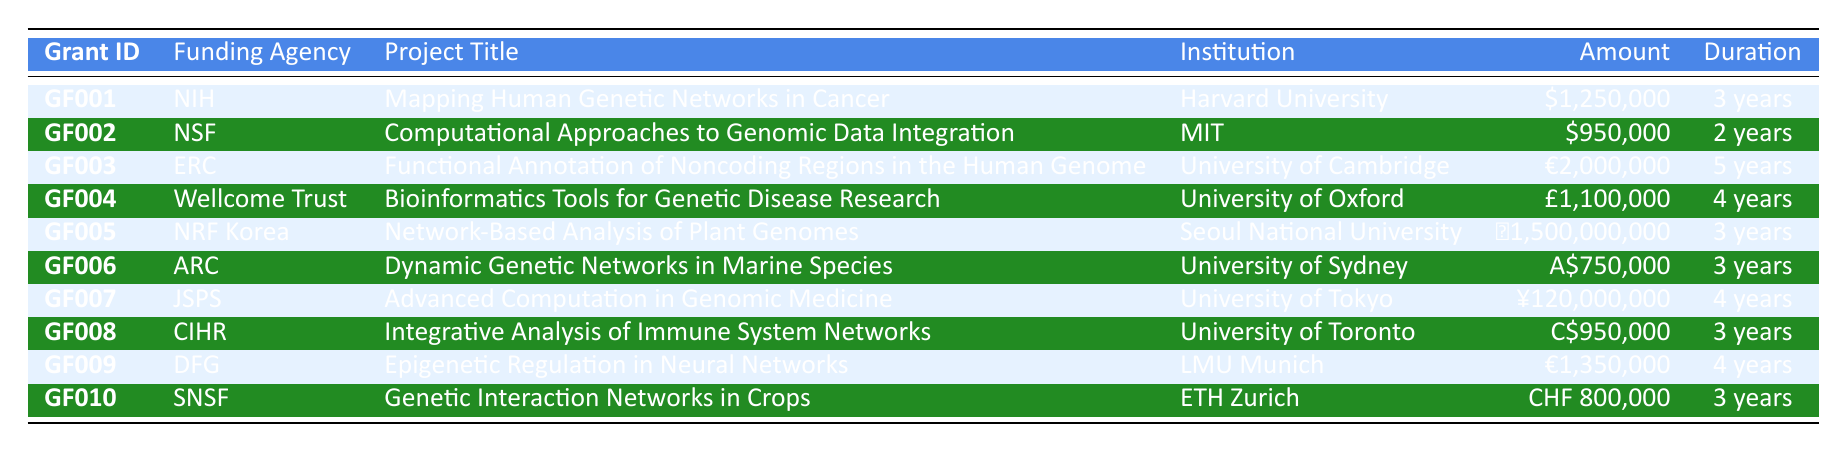What is the amount awarded for the project titled "Mapping Human Genetic Networks in Cancer"? From the table, we can see the row corresponding to the project "Mapping Human Genetic Networks in Cancer" under the Project Title column. The Amount column shows "$1,250,000".
Answer: $1,250,000 Which institution received funding from the National Science Foundation? Looking for the row where the Funding Agency is "National Science Foundation". The corresponding Institution in that row is "Massachusetts Institute of Technology".
Answer: Massachusetts Institute of Technology What is the total amount awarded to projects with a duration of 4 years? We need to identify the projects with a duration of 4 years, which are: "Bioinformatics Tools for Genetic Disease Research" (£1,100,000) and "Epigenetic Regulation in Neural Networks" (€1,350,000). Converting these to a common currency or just summing them up directly: £1,100,000 + €1,350,000. Thus, the total is £1,100,000 and €1,350,000, but can't sum directly without conversion rates provided. Let's note it down as two amounts.
Answer: £1,100,000 and €1,350,000 Is the project "Dynamic Genetic Networks in Marine Species" funded by an Australian funding agency? We check the project titled "Dynamic Genetic Networks in Marine Species" and find that its Funding Agency is "Australian Research Council." Therefore, the answer is yes, as it indicates a funding source from Australia.
Answer: Yes Which project has the highest amount awarded in USD? From the table, we review all the amounts awarded in USD and find that "Mapping Human Genetic Networks in Cancer" has the highest amount of $1,250,000. We confirm that there are no other amounts in USD that surpass this value.
Answer: $1,250,000 What is the average amount awarded across all projects? We will sum all the amounts awarded: $1,250,000 + $950,000 + €2,000,000 + £1,100,000 + ₩1,500,000,000 + A$750,000 + ¥120,000,000 + C$950,000 + €1,350,000 + CHF 800,000. As these amounts are in different currencies, we cannot compute a straightforward average without currency conversion. Once we calculate and convert them into a common currency, we will have the total and can divide it by 10 (the total number of projects) to find the average.
Answer: Average cannot be calculated without currency conversion How many projects were awarded funding by the European Research Council? By reviewing the table, we can see that there is only one row where the Funding Agency is "European Research Council", which indicates that only one project received funding from this agency.
Answer: 1 Which project is associated with Dr. Albert Einstein? In the table, we look for the row with "Dr. Albert Einstein" listed under the PI_Name column, which corresponds to the project "Genetic Interaction Networks in Crops".
Answer: Genetic Interaction Networks in Crops 